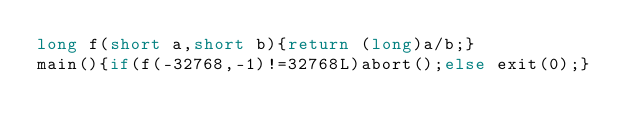<code> <loc_0><loc_0><loc_500><loc_500><_C_>long f(short a,short b){return (long)a/b;}
main(){if(f(-32768,-1)!=32768L)abort();else exit(0);}
</code> 